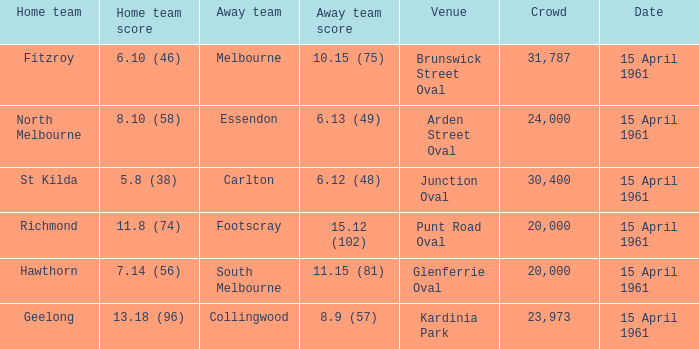What was the score for the home team St Kilda? 5.8 (38). 